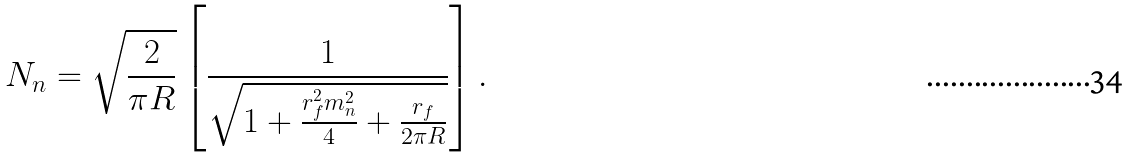Convert formula to latex. <formula><loc_0><loc_0><loc_500><loc_500>N _ { n } = \sqrt { \frac { 2 } { \pi R } } \left [ \frac { 1 } { \sqrt { 1 + \frac { r _ { f } ^ { 2 } m _ { n } ^ { 2 } } { 4 } + \frac { r _ { f } } { 2 \pi R } } } \right ] .</formula> 